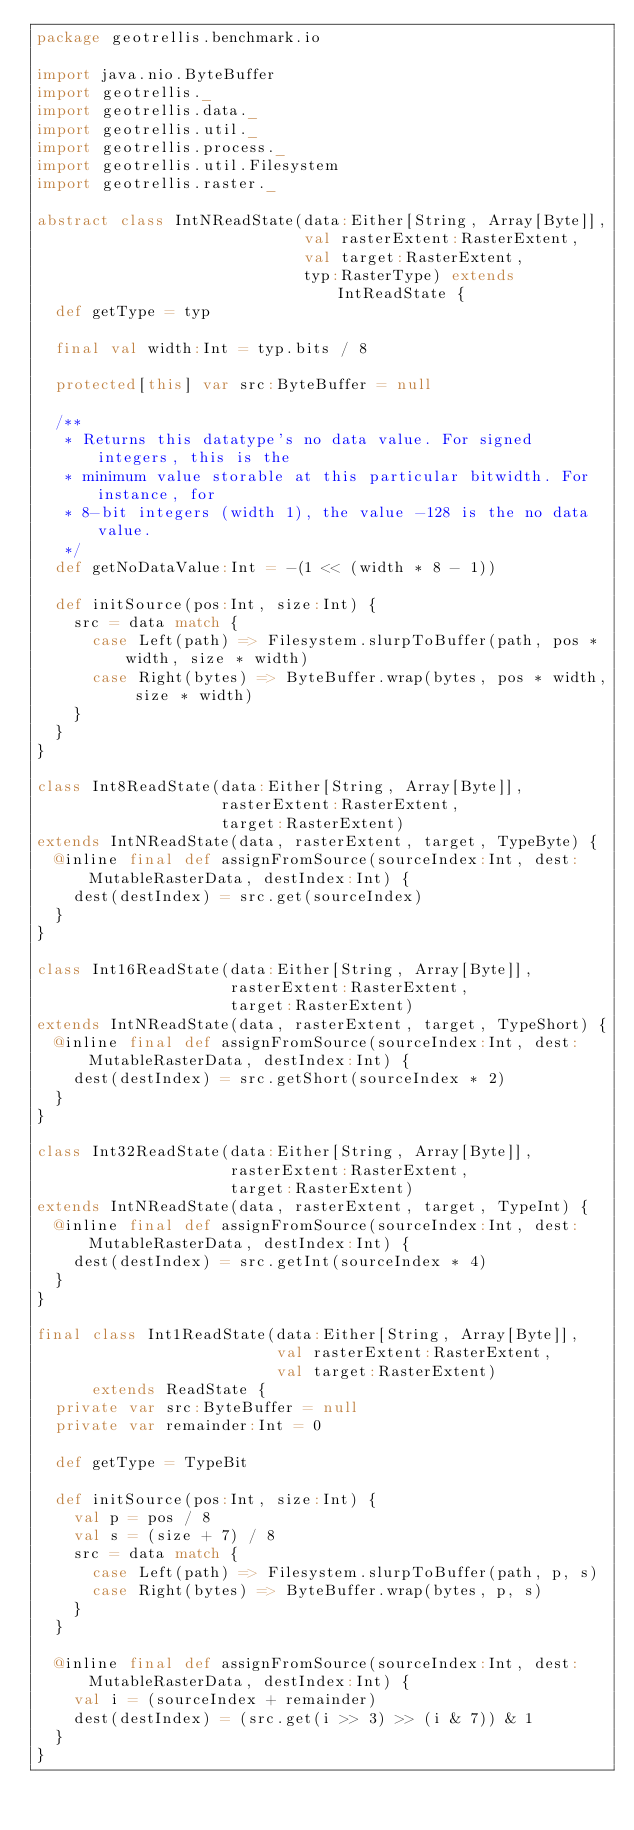Convert code to text. <code><loc_0><loc_0><loc_500><loc_500><_Scala_>package geotrellis.benchmark.io

import java.nio.ByteBuffer
import geotrellis._
import geotrellis.data._
import geotrellis.util._
import geotrellis.process._
import geotrellis.util.Filesystem
import geotrellis.raster._

abstract class IntNReadState(data:Either[String, Array[Byte]],
                             val rasterExtent:RasterExtent,
                             val target:RasterExtent,
                             typ:RasterType) extends IntReadState {
  def getType = typ

  final val width:Int = typ.bits / 8

  protected[this] var src:ByteBuffer = null

  /**
   * Returns this datatype's no data value. For signed integers, this is the
   * minimum value storable at this particular bitwidth. For instance, for
   * 8-bit integers (width 1), the value -128 is the no data value.
   */
  def getNoDataValue:Int = -(1 << (width * 8 - 1))

  def initSource(pos:Int, size:Int) {
    src = data match {
      case Left(path) => Filesystem.slurpToBuffer(path, pos * width, size * width)
      case Right(bytes) => ByteBuffer.wrap(bytes, pos * width, size * width)
    }
  }
}

class Int8ReadState(data:Either[String, Array[Byte]],
                    rasterExtent:RasterExtent,
                    target:RasterExtent)
extends IntNReadState(data, rasterExtent, target, TypeByte) {
  @inline final def assignFromSource(sourceIndex:Int, dest:MutableRasterData, destIndex:Int) {
    dest(destIndex) = src.get(sourceIndex)
  }
}

class Int16ReadState(data:Either[String, Array[Byte]],
                     rasterExtent:RasterExtent,
                     target:RasterExtent)
extends IntNReadState(data, rasterExtent, target, TypeShort) {
  @inline final def assignFromSource(sourceIndex:Int, dest:MutableRasterData, destIndex:Int) {
    dest(destIndex) = src.getShort(sourceIndex * 2)
  }
}

class Int32ReadState(data:Either[String, Array[Byte]],
                     rasterExtent:RasterExtent,
                     target:RasterExtent)
extends IntNReadState(data, rasterExtent, target, TypeInt) {
  @inline final def assignFromSource(sourceIndex:Int, dest:MutableRasterData, destIndex:Int) {
    dest(destIndex) = src.getInt(sourceIndex * 4)
  }
}

final class Int1ReadState(data:Either[String, Array[Byte]],
                          val rasterExtent:RasterExtent,
                          val target:RasterExtent) 
      extends ReadState {
  private var src:ByteBuffer = null
  private var remainder:Int = 0

  def getType = TypeBit

  def initSource(pos:Int, size:Int) {
    val p = pos / 8
    val s = (size + 7) / 8
    src = data match {
      case Left(path) => Filesystem.slurpToBuffer(path, p, s)
      case Right(bytes) => ByteBuffer.wrap(bytes, p, s)
    }
  }

  @inline final def assignFromSource(sourceIndex:Int, dest:MutableRasterData, destIndex:Int) {
    val i = (sourceIndex + remainder)
    dest(destIndex) = (src.get(i >> 3) >> (i & 7)) & 1
  }
}
</code> 